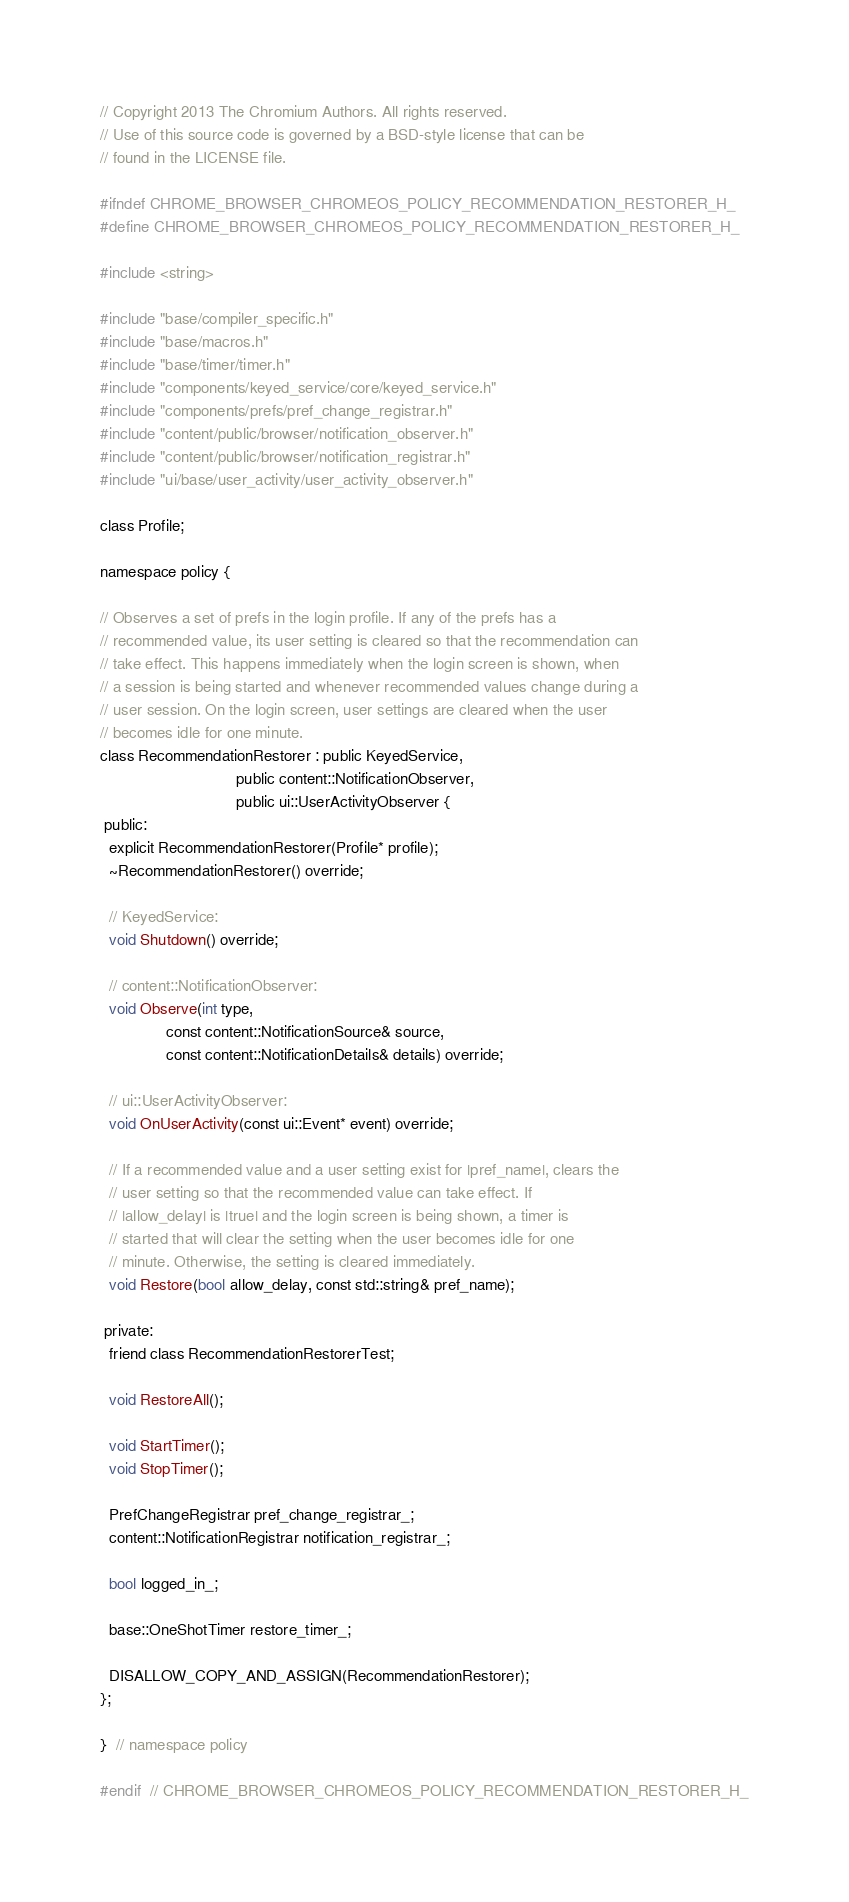Convert code to text. <code><loc_0><loc_0><loc_500><loc_500><_C_>// Copyright 2013 The Chromium Authors. All rights reserved.
// Use of this source code is governed by a BSD-style license that can be
// found in the LICENSE file.

#ifndef CHROME_BROWSER_CHROMEOS_POLICY_RECOMMENDATION_RESTORER_H_
#define CHROME_BROWSER_CHROMEOS_POLICY_RECOMMENDATION_RESTORER_H_

#include <string>

#include "base/compiler_specific.h"
#include "base/macros.h"
#include "base/timer/timer.h"
#include "components/keyed_service/core/keyed_service.h"
#include "components/prefs/pref_change_registrar.h"
#include "content/public/browser/notification_observer.h"
#include "content/public/browser/notification_registrar.h"
#include "ui/base/user_activity/user_activity_observer.h"

class Profile;

namespace policy {

// Observes a set of prefs in the login profile. If any of the prefs has a
// recommended value, its user setting is cleared so that the recommendation can
// take effect. This happens immediately when the login screen is shown, when
// a session is being started and whenever recommended values change during a
// user session. On the login screen, user settings are cleared when the user
// becomes idle for one minute.
class RecommendationRestorer : public KeyedService,
                               public content::NotificationObserver,
                               public ui::UserActivityObserver {
 public:
  explicit RecommendationRestorer(Profile* profile);
  ~RecommendationRestorer() override;

  // KeyedService:
  void Shutdown() override;

  // content::NotificationObserver:
  void Observe(int type,
               const content::NotificationSource& source,
               const content::NotificationDetails& details) override;

  // ui::UserActivityObserver:
  void OnUserActivity(const ui::Event* event) override;

  // If a recommended value and a user setting exist for |pref_name|, clears the
  // user setting so that the recommended value can take effect. If
  // |allow_delay| is |true| and the login screen is being shown, a timer is
  // started that will clear the setting when the user becomes idle for one
  // minute. Otherwise, the setting is cleared immediately.
  void Restore(bool allow_delay, const std::string& pref_name);

 private:
  friend class RecommendationRestorerTest;

  void RestoreAll();

  void StartTimer();
  void StopTimer();

  PrefChangeRegistrar pref_change_registrar_;
  content::NotificationRegistrar notification_registrar_;

  bool logged_in_;

  base::OneShotTimer restore_timer_;

  DISALLOW_COPY_AND_ASSIGN(RecommendationRestorer);
};

}  // namespace policy

#endif  // CHROME_BROWSER_CHROMEOS_POLICY_RECOMMENDATION_RESTORER_H_
</code> 